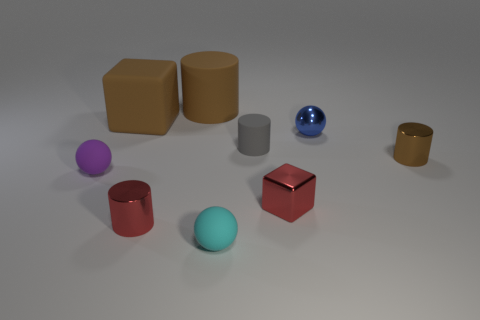Can you tell me about the colors in this image? Certainly, the objects in this image present a muted palette with primarily matte finishes. There's a diverse range of colors including tan, red, purple, blue, and aqua. Moreover, one object notably has a shiny, reflective surface, which is a brilliant blue sphere that stands out in contrast to the matte textures around it. 